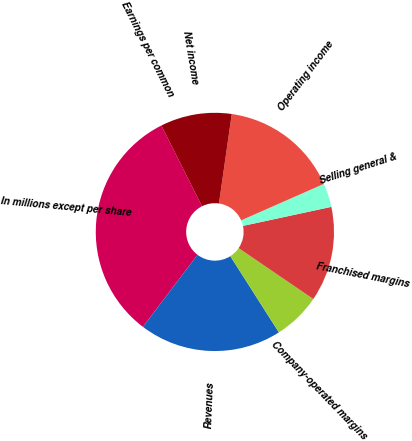<chart> <loc_0><loc_0><loc_500><loc_500><pie_chart><fcel>In millions except per share<fcel>Revenues<fcel>Company-operated margins<fcel>Franchised margins<fcel>Selling general &<fcel>Operating income<fcel>Net income<fcel>Earnings per common<nl><fcel>32.26%<fcel>19.35%<fcel>6.45%<fcel>12.9%<fcel>3.23%<fcel>16.13%<fcel>9.68%<fcel>0.0%<nl></chart> 